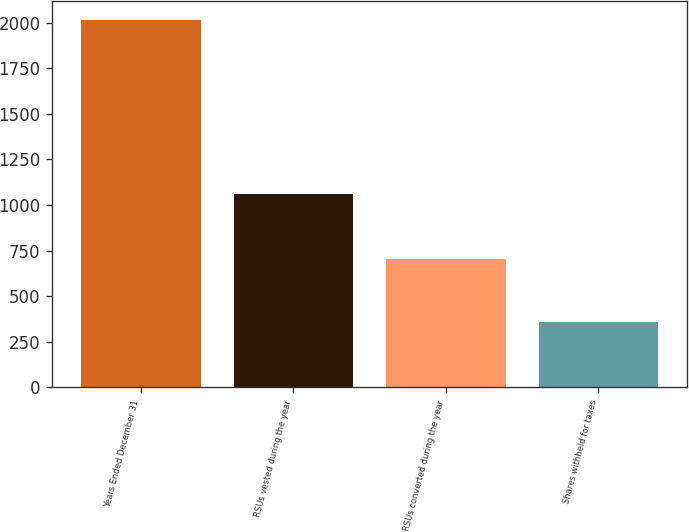Convert chart. <chart><loc_0><loc_0><loc_500><loc_500><bar_chart><fcel>Years Ended December 31<fcel>RSUs vested during the year<fcel>RSUs converted during the year<fcel>Shares withheld for taxes<nl><fcel>2016<fcel>1063<fcel>705<fcel>358<nl></chart> 